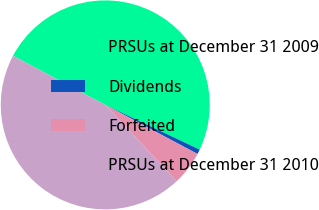Convert chart. <chart><loc_0><loc_0><loc_500><loc_500><pie_chart><fcel>PRSUs at December 31 2009<fcel>Dividends<fcel>Forfeited<fcel>PRSUs at December 31 2010<nl><fcel>49.26%<fcel>0.74%<fcel>5.26%<fcel>44.74%<nl></chart> 